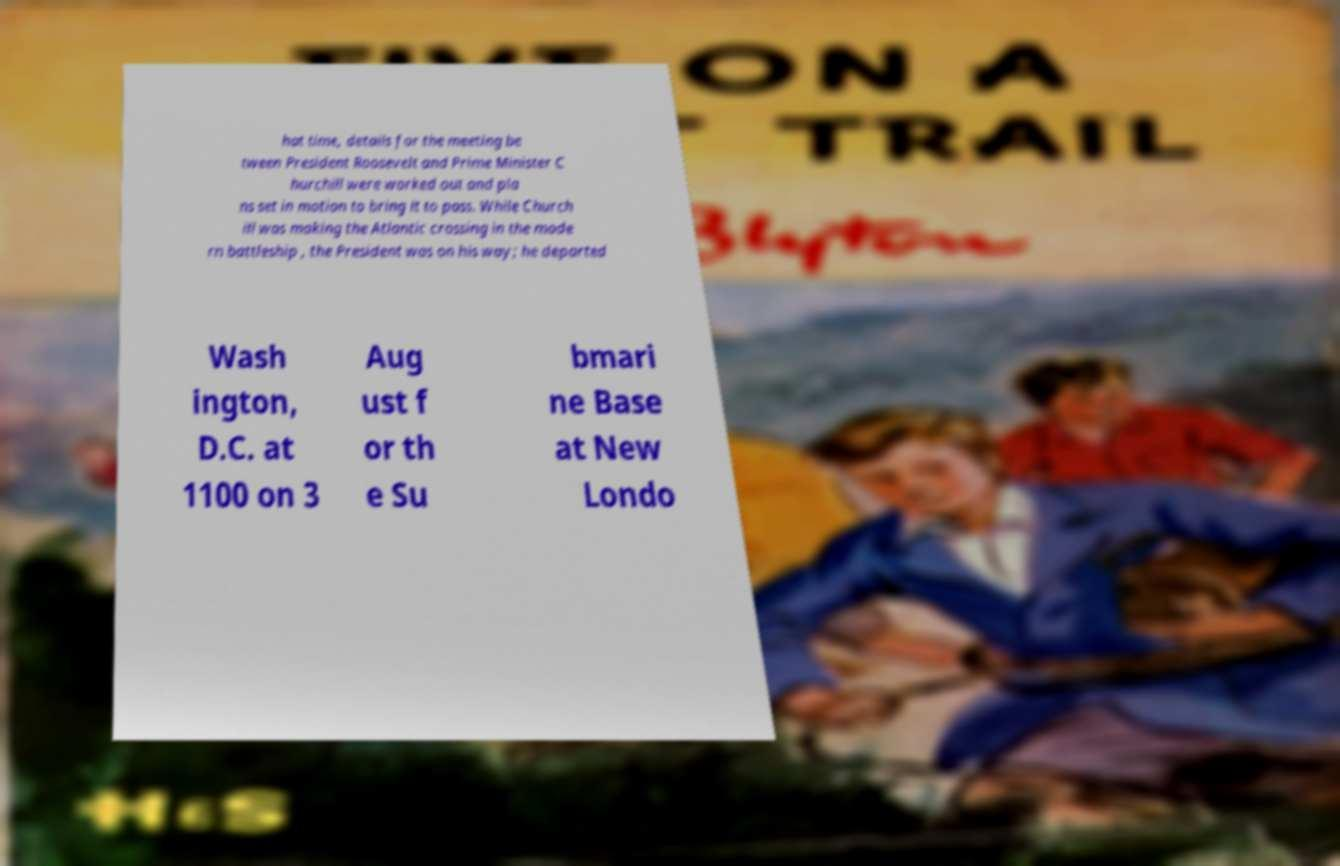There's text embedded in this image that I need extracted. Can you transcribe it verbatim? hat time, details for the meeting be tween President Roosevelt and Prime Minister C hurchill were worked out and pla ns set in motion to bring it to pass. While Church ill was making the Atlantic crossing in the mode rn battleship , the President was on his way; he departed Wash ington, D.C. at 1100 on 3 Aug ust f or th e Su bmari ne Base at New Londo 